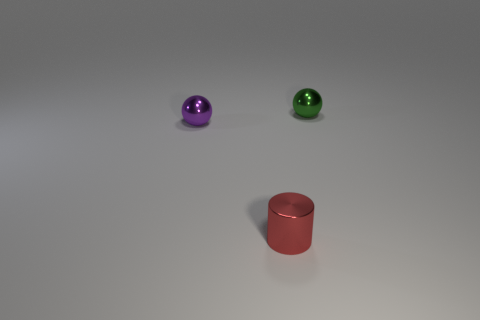There is a purple metal object left of the green thing; does it have the same shape as the green shiny object?
Your answer should be compact. Yes. How many blue things are tiny objects or cylinders?
Ensure brevity in your answer.  0. Are there the same number of small green balls in front of the purple metal sphere and tiny shiny spheres that are left of the tiny red shiny cylinder?
Your response must be concise. No. What is the color of the ball that is in front of the metallic object behind the ball that is to the left of the tiny red object?
Your response must be concise. Purple. Is there anything else of the same color as the metallic cylinder?
Ensure brevity in your answer.  No. There is a sphere that is right of the shiny cylinder; how big is it?
Your response must be concise. Small. What shape is the green object that is the same size as the red cylinder?
Provide a short and direct response. Sphere. Do the small sphere that is left of the red object and the tiny thing that is to the right of the red metallic thing have the same material?
Your answer should be compact. Yes. What size is the metal ball that is behind the tiny metal sphere in front of the small thing that is behind the purple sphere?
Your answer should be compact. Small. Do the small purple shiny object behind the red metal object and the small shiny object that is in front of the purple thing have the same shape?
Provide a short and direct response. No. 